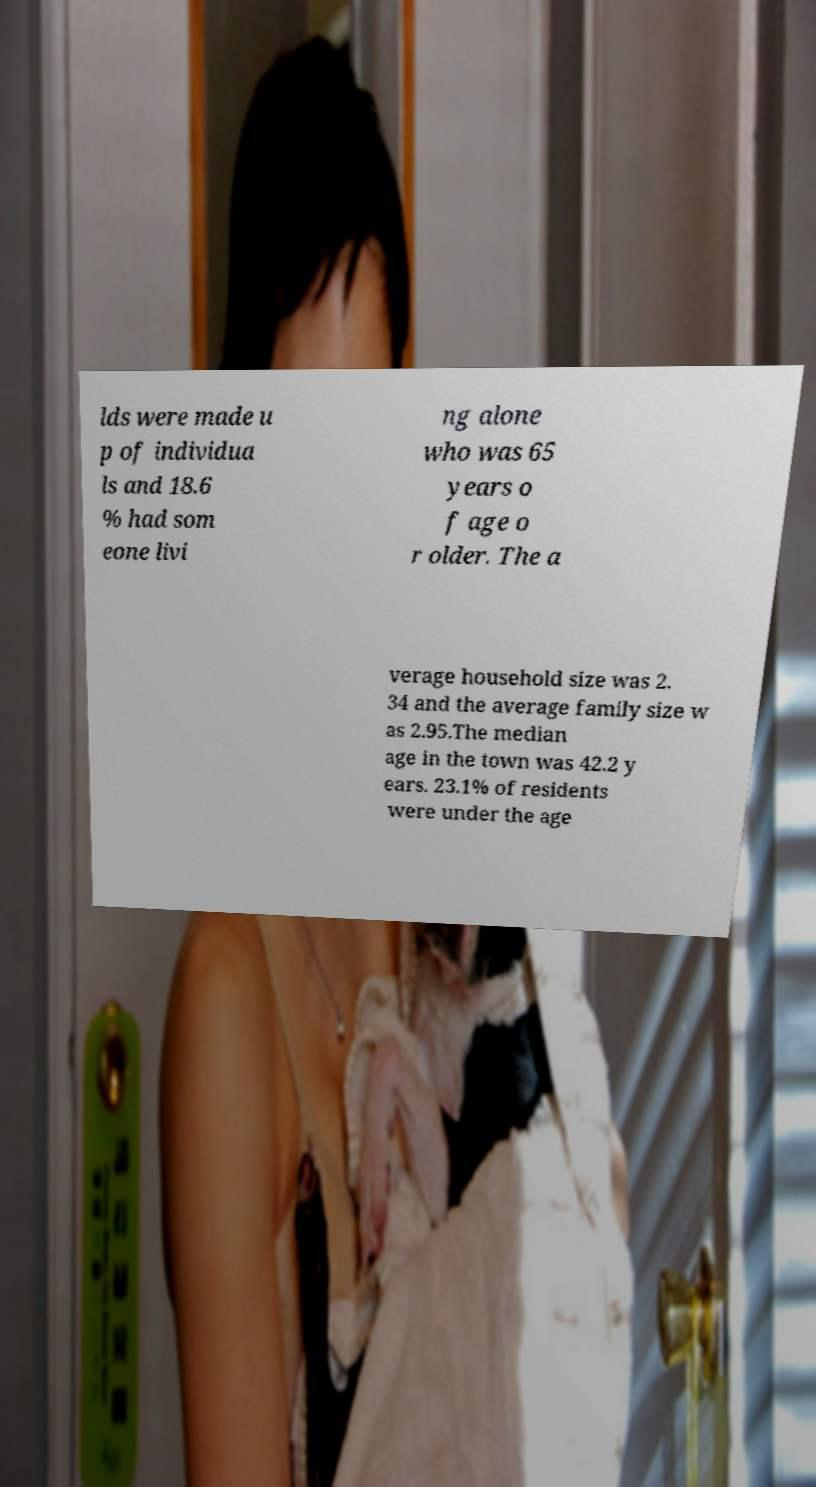For documentation purposes, I need the text within this image transcribed. Could you provide that? lds were made u p of individua ls and 18.6 % had som eone livi ng alone who was 65 years o f age o r older. The a verage household size was 2. 34 and the average family size w as 2.95.The median age in the town was 42.2 y ears. 23.1% of residents were under the age 